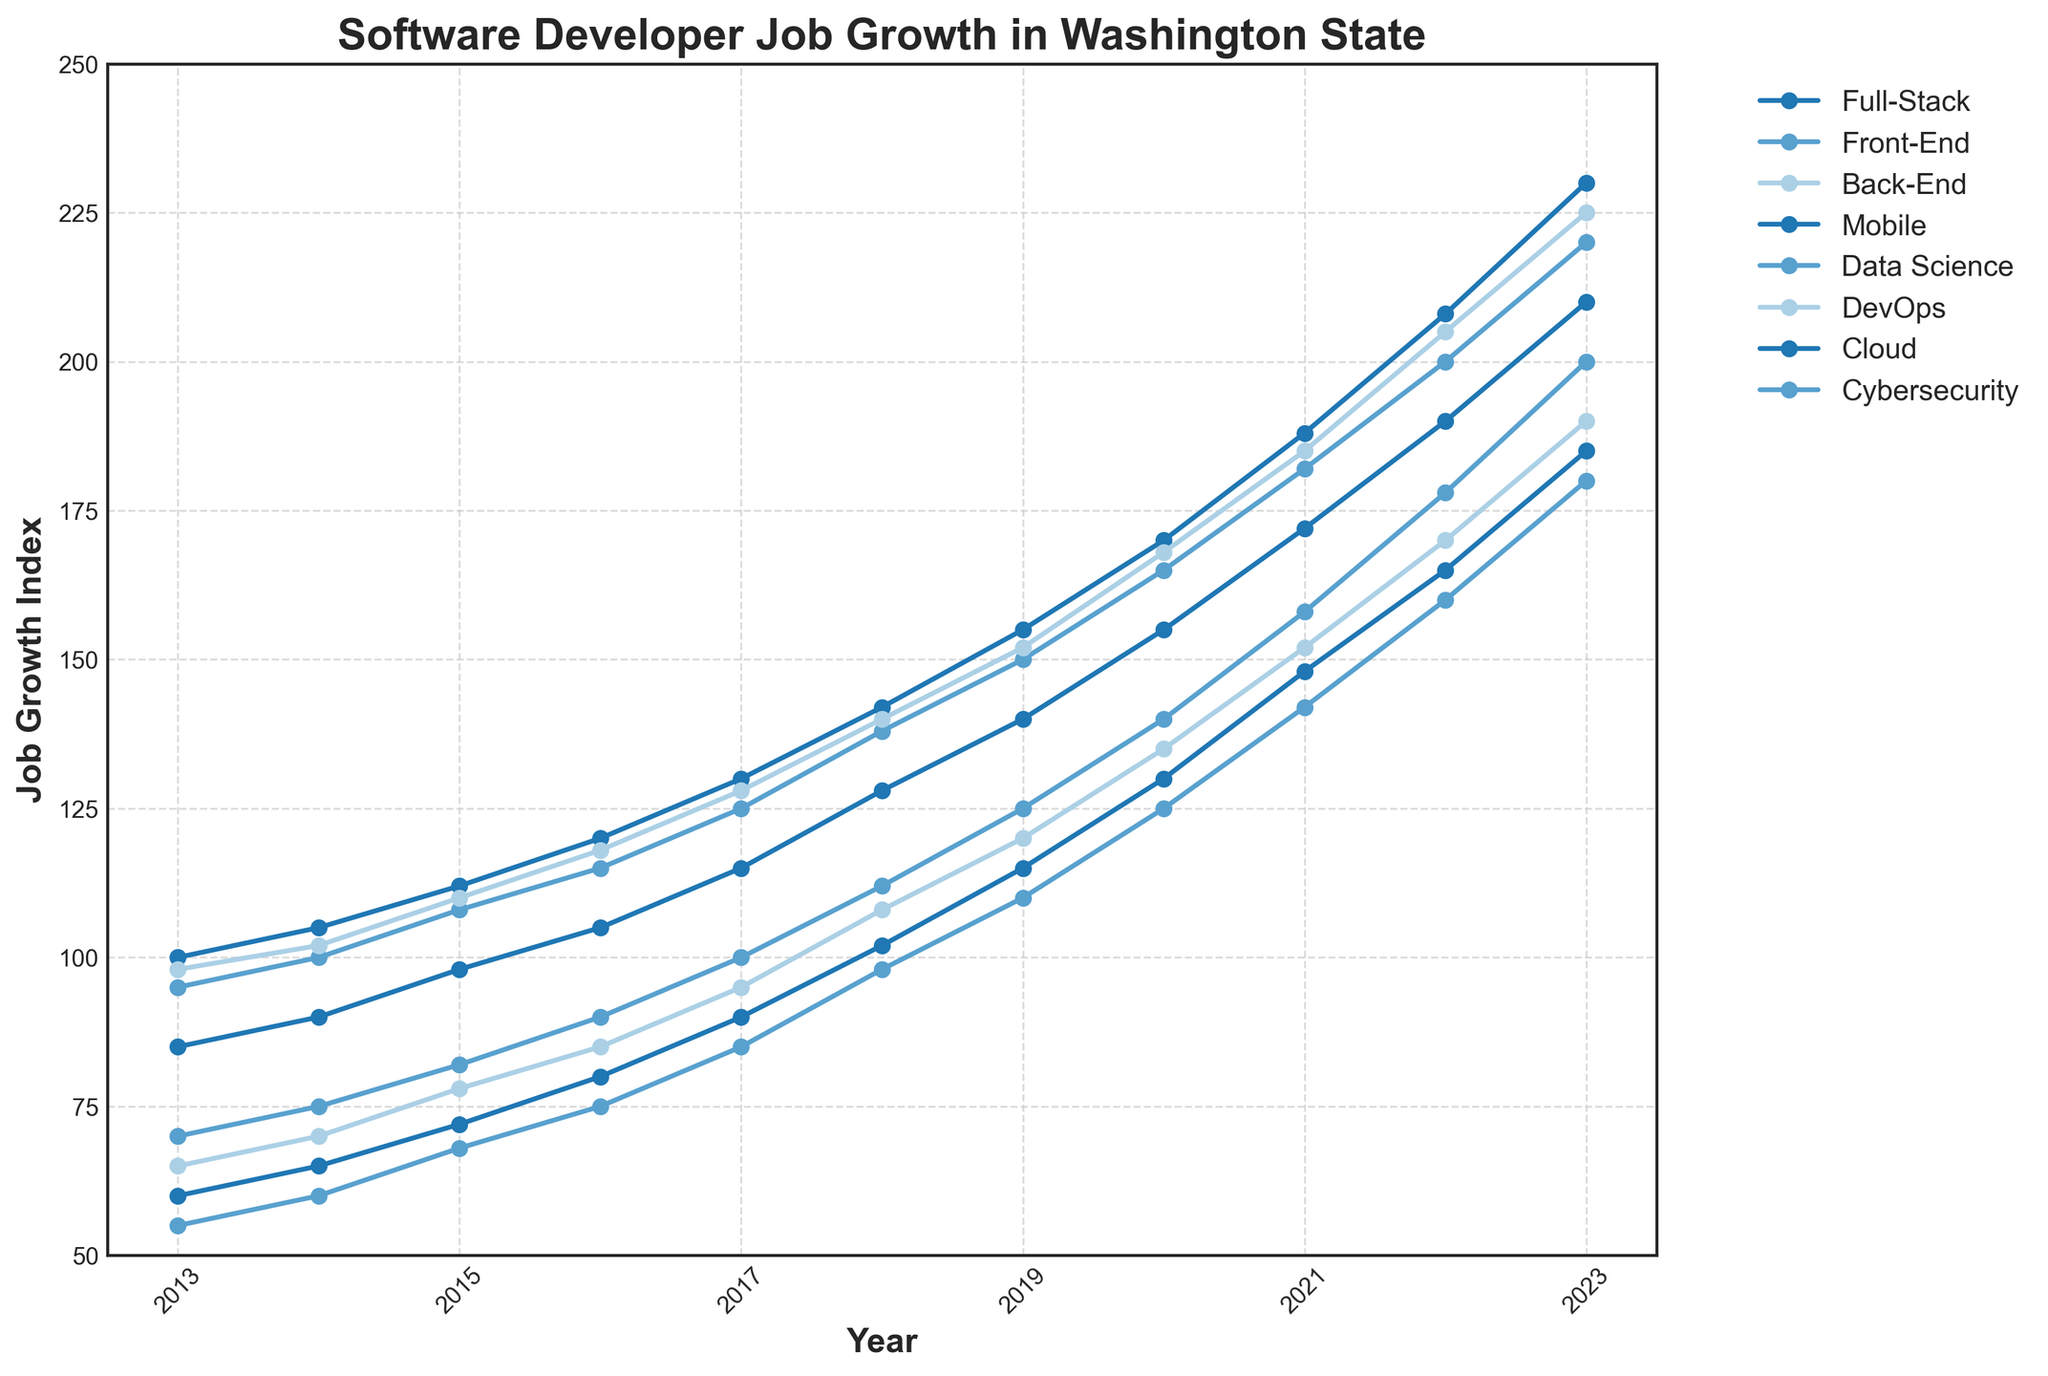what year did the Full-Stack specialization surpass 200 in job growth index? The plot indicates that the Full-Stack specialization surpassed 200 in job growth index in 2022. This can be identified by tracing the Full-Stack line and finding the year where it crosses the 200 mark.
Answer: 2022 Between which two consecutive years did Cybersecurity show the highest increase in job growth index? To determine this, we need to calculate the difference in Cybersecurity job growth index for each consecutive year and identify the highest increase. The increases are: 5 (2013-2014), 8 (2014-2015), 7 (2015-2016), 10 (2016-2017), 13 (2017-2018), 12 (2018-2019), 15 (2019-2020), 17 (2020-2021), 18 (2021-2022), and 20 (2022-2023). The highest increase is 20 from 2022 to 2023.
Answer: 2022-2023 Which specialization had the fastest job growth rate from 2013 to 2023? To answer this, compare the increases in job growth indices for each specialization from 2013 to 2023. The differences are: 
Full-Stack: 130 (230-100) 
Front-End: 125 (220-95) 
Back-End: 127 (225-98)
Mobile: 125 (210-85)
Data Science: 130 (200-70)
DevOps: 125 (190-65)
Cloud: 125 (185-60)
Cybersecurity: 125 (180-55)
Both Full-Stack and Data Science have the largest increase of 130.
Answer: Full-Stack and Data Science In 2017, which specialization had the lowest job growth index? By observing the plot at the year 2017, the line that is positioned lowest on the y-axis represents the specialization with the lowest index. In 2017, this is Cybersecurity.
Answer: Cybersecurity How many specializations had a job growth index above 150 in 2019? In the plot, count the number of lines that are above the 150 mark on the y-axis in the year 2017. Full-Stack (155), Front-End (150), Back-End (152), and Mobile (140). Only 4 surpass the 150 mark.
Answer: 4 